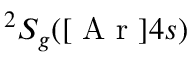Convert formula to latex. <formula><loc_0><loc_0><loc_500><loc_500>^ { 2 } S _ { g } ( [ A r ] 4 s )</formula> 